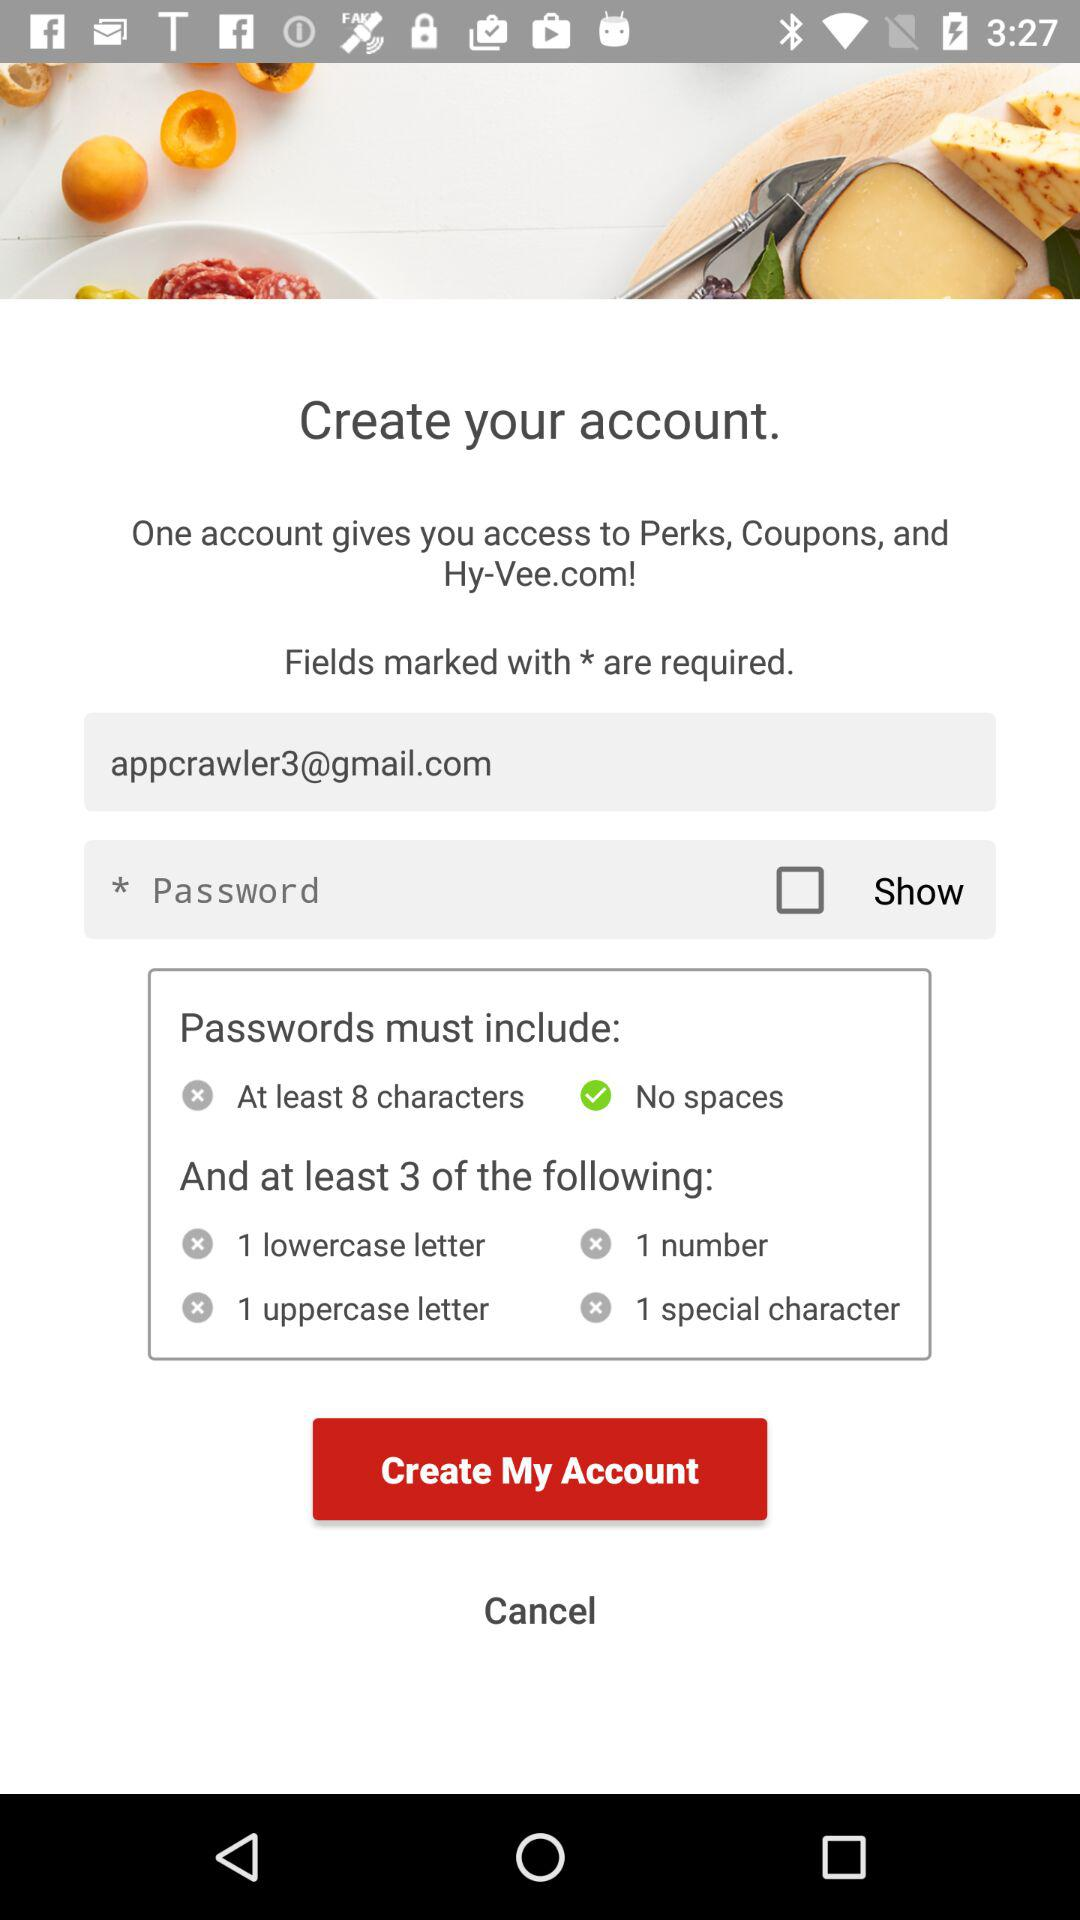What is the minimum number of characters required for a password?` The minimum number of characters required for a password is 8. 